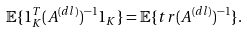Convert formula to latex. <formula><loc_0><loc_0><loc_500><loc_500>\mathbb { E } \{ 1 _ { K } ^ { T } ( A ^ { ( d l ) } ) ^ { - 1 } 1 _ { K } \} = \mathbb { E } \{ t r ( A ^ { ( d l ) } ) ^ { - 1 } \} .</formula> 